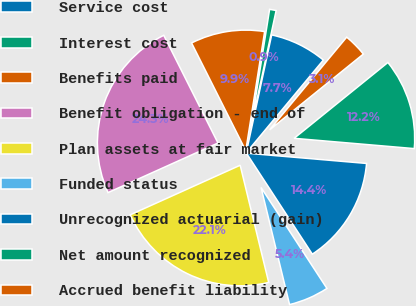<chart> <loc_0><loc_0><loc_500><loc_500><pie_chart><fcel>Service cost<fcel>Interest cost<fcel>Benefits paid<fcel>Benefit obligation - end of<fcel>Plan assets at fair market<fcel>Funded status<fcel>Unrecognized actuarial (gain)<fcel>Net amount recognized<fcel>Accrued benefit liability<nl><fcel>7.66%<fcel>0.88%<fcel>9.92%<fcel>24.32%<fcel>22.06%<fcel>5.4%<fcel>14.44%<fcel>12.18%<fcel>3.14%<nl></chart> 